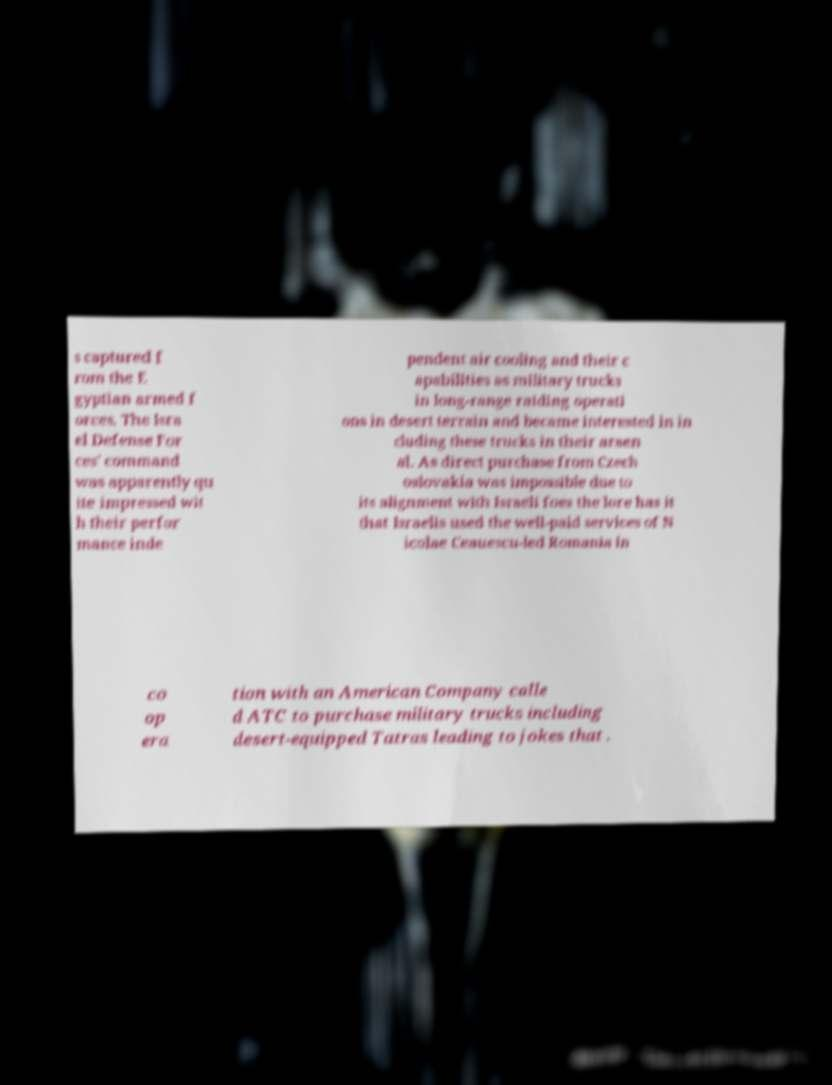Could you extract and type out the text from this image? s captured f rom the E gyptian armed f orces. The Isra el Defense For ces' command was apparently qu ite impressed wit h their perfor mance inde pendent air cooling and their c apabilities as military trucks in long-range raiding operati ons in desert terrain and became interested in in cluding these trucks in their arsen al. As direct purchase from Czech oslovakia was impossible due to its alignment with Israeli foes the lore has it that Israelis used the well-paid services of N icolae Ceauescu-led Romania in co op era tion with an American Company calle d ATC to purchase military trucks including desert-equipped Tatras leading to jokes that . 